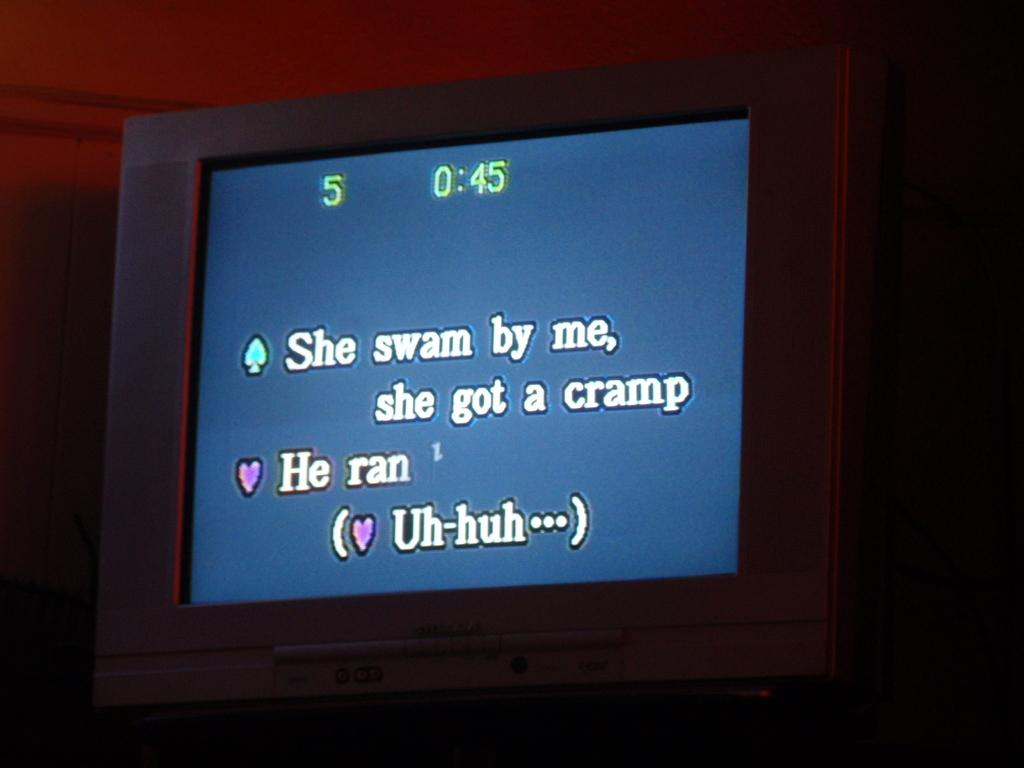<image>
Give a short and clear explanation of the subsequent image. A blue screen shows the lyrics to a song for karoke. 